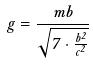<formula> <loc_0><loc_0><loc_500><loc_500>g = \frac { m b } { \sqrt { 7 \cdot \frac { b ^ { 2 } } { c ^ { 2 } } } }</formula> 